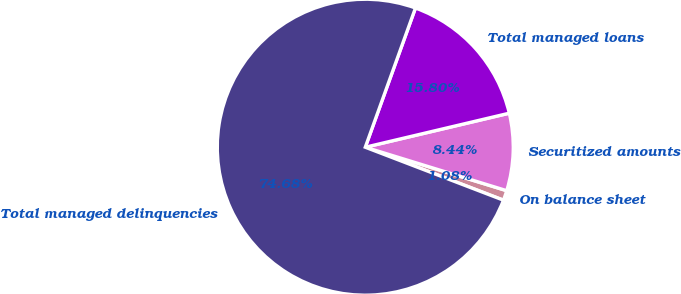Convert chart to OTSL. <chart><loc_0><loc_0><loc_500><loc_500><pie_chart><fcel>On balance sheet<fcel>Securitized amounts<fcel>Total managed loans<fcel>Total managed delinquencies<nl><fcel>1.08%<fcel>8.44%<fcel>15.8%<fcel>74.68%<nl></chart> 